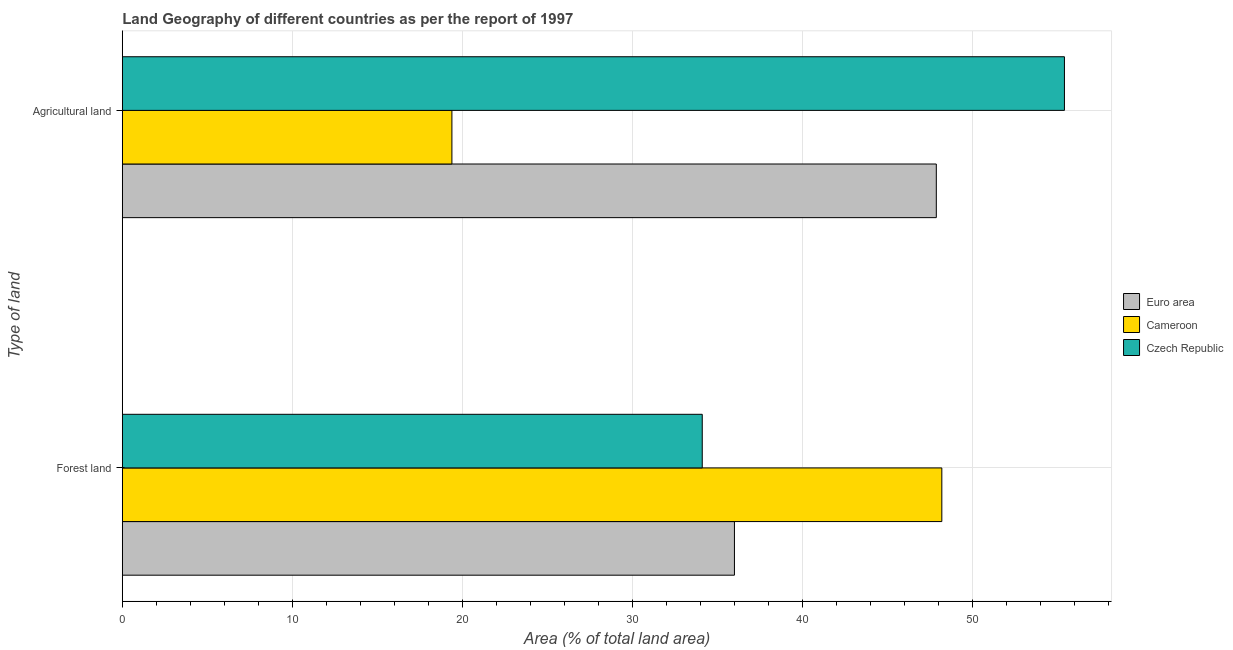How many groups of bars are there?
Give a very brief answer. 2. Are the number of bars per tick equal to the number of legend labels?
Ensure brevity in your answer.  Yes. Are the number of bars on each tick of the Y-axis equal?
Make the answer very short. Yes. How many bars are there on the 2nd tick from the top?
Your response must be concise. 3. What is the label of the 1st group of bars from the top?
Offer a terse response. Agricultural land. What is the percentage of land area under forests in Euro area?
Your answer should be very brief. 35.99. Across all countries, what is the maximum percentage of land area under forests?
Your answer should be compact. 48.18. Across all countries, what is the minimum percentage of land area under agriculture?
Keep it short and to the point. 19.38. In which country was the percentage of land area under agriculture maximum?
Make the answer very short. Czech Republic. In which country was the percentage of land area under forests minimum?
Your response must be concise. Czech Republic. What is the total percentage of land area under forests in the graph?
Your answer should be compact. 118.27. What is the difference between the percentage of land area under agriculture in Czech Republic and that in Euro area?
Offer a very short reply. 7.53. What is the difference between the percentage of land area under forests in Czech Republic and the percentage of land area under agriculture in Euro area?
Make the answer very short. -13.76. What is the average percentage of land area under agriculture per country?
Provide a short and direct response. 40.88. What is the difference between the percentage of land area under agriculture and percentage of land area under forests in Czech Republic?
Keep it short and to the point. 21.29. What is the ratio of the percentage of land area under forests in Cameroon to that in Euro area?
Make the answer very short. 1.34. In how many countries, is the percentage of land area under forests greater than the average percentage of land area under forests taken over all countries?
Make the answer very short. 1. What does the 1st bar from the top in Forest land represents?
Offer a terse response. Czech Republic. What does the 3rd bar from the bottom in Forest land represents?
Provide a succinct answer. Czech Republic. How many bars are there?
Make the answer very short. 6. How many countries are there in the graph?
Keep it short and to the point. 3. What is the difference between two consecutive major ticks on the X-axis?
Your answer should be very brief. 10. Are the values on the major ticks of X-axis written in scientific E-notation?
Your response must be concise. No. Where does the legend appear in the graph?
Your answer should be very brief. Center right. How many legend labels are there?
Make the answer very short. 3. How are the legend labels stacked?
Make the answer very short. Vertical. What is the title of the graph?
Provide a short and direct response. Land Geography of different countries as per the report of 1997. What is the label or title of the X-axis?
Provide a succinct answer. Area (% of total land area). What is the label or title of the Y-axis?
Give a very brief answer. Type of land. What is the Area (% of total land area) of Euro area in Forest land?
Keep it short and to the point. 35.99. What is the Area (% of total land area) of Cameroon in Forest land?
Offer a very short reply. 48.18. What is the Area (% of total land area) of Czech Republic in Forest land?
Your response must be concise. 34.1. What is the Area (% of total land area) of Euro area in Agricultural land?
Offer a very short reply. 47.86. What is the Area (% of total land area) of Cameroon in Agricultural land?
Offer a terse response. 19.38. What is the Area (% of total land area) of Czech Republic in Agricultural land?
Your answer should be compact. 55.39. Across all Type of land, what is the maximum Area (% of total land area) in Euro area?
Provide a short and direct response. 47.86. Across all Type of land, what is the maximum Area (% of total land area) in Cameroon?
Your answer should be compact. 48.18. Across all Type of land, what is the maximum Area (% of total land area) in Czech Republic?
Offer a terse response. 55.39. Across all Type of land, what is the minimum Area (% of total land area) of Euro area?
Your answer should be compact. 35.99. Across all Type of land, what is the minimum Area (% of total land area) of Cameroon?
Ensure brevity in your answer.  19.38. Across all Type of land, what is the minimum Area (% of total land area) in Czech Republic?
Provide a short and direct response. 34.1. What is the total Area (% of total land area) of Euro area in the graph?
Provide a short and direct response. 83.85. What is the total Area (% of total land area) of Cameroon in the graph?
Make the answer very short. 67.56. What is the total Area (% of total land area) of Czech Republic in the graph?
Offer a very short reply. 89.49. What is the difference between the Area (% of total land area) in Euro area in Forest land and that in Agricultural land?
Offer a terse response. -11.87. What is the difference between the Area (% of total land area) of Cameroon in Forest land and that in Agricultural land?
Offer a terse response. 28.8. What is the difference between the Area (% of total land area) of Czech Republic in Forest land and that in Agricultural land?
Offer a terse response. -21.29. What is the difference between the Area (% of total land area) of Euro area in Forest land and the Area (% of total land area) of Cameroon in Agricultural land?
Your answer should be compact. 16.61. What is the difference between the Area (% of total land area) in Euro area in Forest land and the Area (% of total land area) in Czech Republic in Agricultural land?
Make the answer very short. -19.4. What is the difference between the Area (% of total land area) in Cameroon in Forest land and the Area (% of total land area) in Czech Republic in Agricultural land?
Make the answer very short. -7.21. What is the average Area (% of total land area) in Euro area per Type of land?
Your answer should be compact. 41.92. What is the average Area (% of total land area) of Cameroon per Type of land?
Offer a terse response. 33.78. What is the average Area (% of total land area) in Czech Republic per Type of land?
Your response must be concise. 44.74. What is the difference between the Area (% of total land area) of Euro area and Area (% of total land area) of Cameroon in Forest land?
Provide a succinct answer. -12.19. What is the difference between the Area (% of total land area) in Euro area and Area (% of total land area) in Czech Republic in Forest land?
Keep it short and to the point. 1.89. What is the difference between the Area (% of total land area) in Cameroon and Area (% of total land area) in Czech Republic in Forest land?
Keep it short and to the point. 14.09. What is the difference between the Area (% of total land area) in Euro area and Area (% of total land area) in Cameroon in Agricultural land?
Give a very brief answer. 28.48. What is the difference between the Area (% of total land area) in Euro area and Area (% of total land area) in Czech Republic in Agricultural land?
Provide a short and direct response. -7.53. What is the difference between the Area (% of total land area) in Cameroon and Area (% of total land area) in Czech Republic in Agricultural land?
Ensure brevity in your answer.  -36.01. What is the ratio of the Area (% of total land area) in Euro area in Forest land to that in Agricultural land?
Give a very brief answer. 0.75. What is the ratio of the Area (% of total land area) in Cameroon in Forest land to that in Agricultural land?
Make the answer very short. 2.49. What is the ratio of the Area (% of total land area) of Czech Republic in Forest land to that in Agricultural land?
Make the answer very short. 0.62. What is the difference between the highest and the second highest Area (% of total land area) of Euro area?
Provide a succinct answer. 11.87. What is the difference between the highest and the second highest Area (% of total land area) in Cameroon?
Ensure brevity in your answer.  28.8. What is the difference between the highest and the second highest Area (% of total land area) of Czech Republic?
Provide a succinct answer. 21.29. What is the difference between the highest and the lowest Area (% of total land area) of Euro area?
Provide a short and direct response. 11.87. What is the difference between the highest and the lowest Area (% of total land area) of Cameroon?
Your answer should be compact. 28.8. What is the difference between the highest and the lowest Area (% of total land area) of Czech Republic?
Make the answer very short. 21.29. 